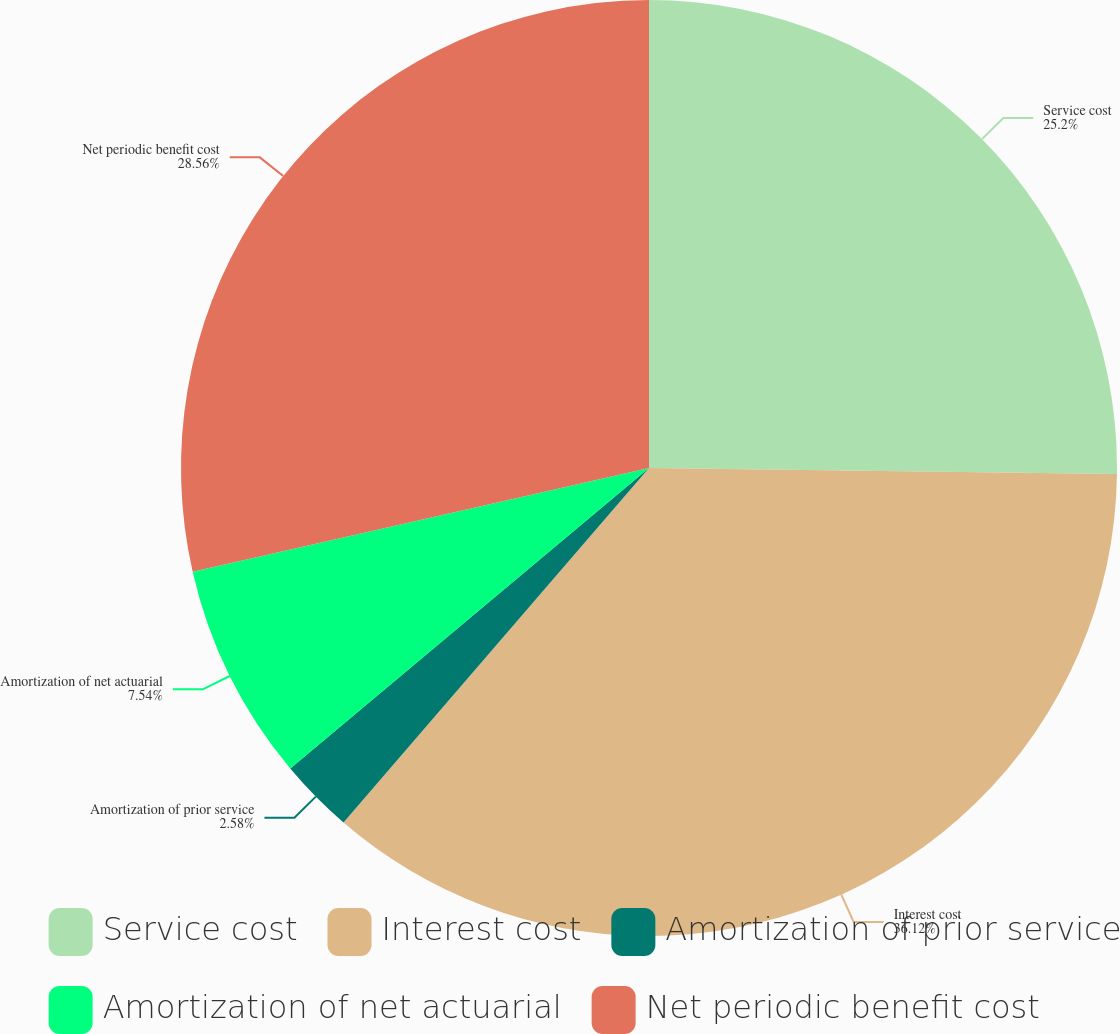<chart> <loc_0><loc_0><loc_500><loc_500><pie_chart><fcel>Service cost<fcel>Interest cost<fcel>Amortization of prior service<fcel>Amortization of net actuarial<fcel>Net periodic benefit cost<nl><fcel>25.2%<fcel>36.12%<fcel>2.58%<fcel>7.54%<fcel>28.56%<nl></chart> 